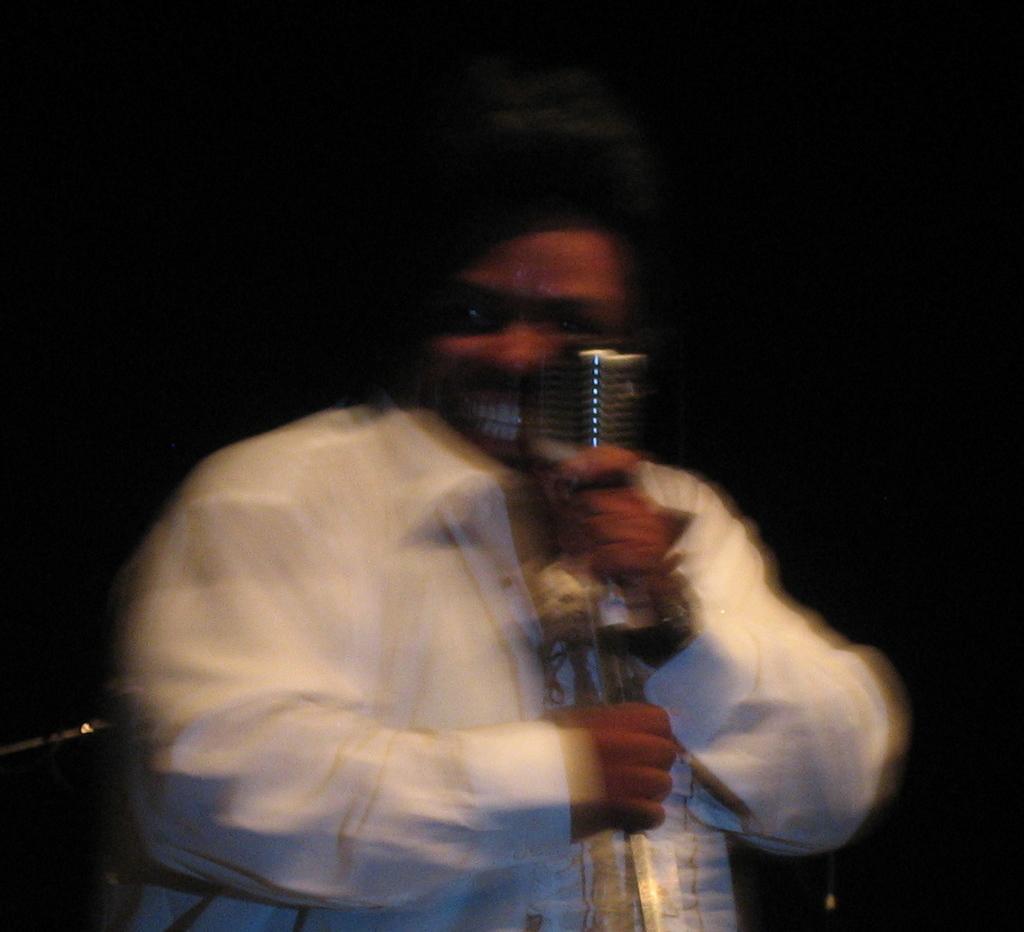Please provide a concise description of this image. In this picture there is a man in the center of the image, by holding a mic in his hands. 